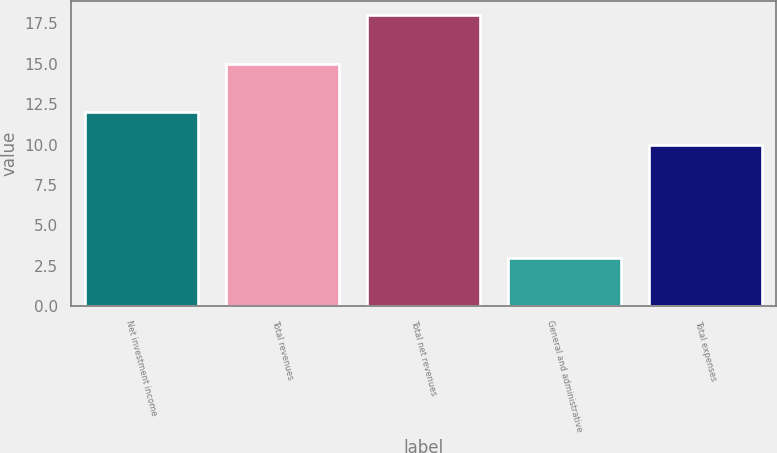Convert chart. <chart><loc_0><loc_0><loc_500><loc_500><bar_chart><fcel>Net investment income<fcel>Total revenues<fcel>Total net revenues<fcel>General and administrative<fcel>Total expenses<nl><fcel>12<fcel>15<fcel>18<fcel>3<fcel>10<nl></chart> 